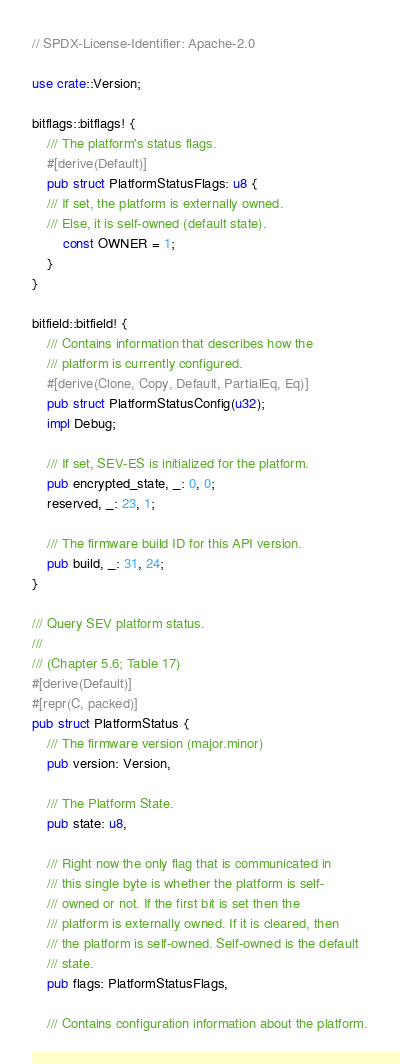<code> <loc_0><loc_0><loc_500><loc_500><_Rust_>// SPDX-License-Identifier: Apache-2.0

use crate::Version;

bitflags::bitflags! {
    /// The platform's status flags.
    #[derive(Default)]
    pub struct PlatformStatusFlags: u8 {
    /// If set, the platform is externally owned.
    /// Else, it is self-owned (default state).
        const OWNER = 1;
    }
}

bitfield::bitfield! {
    /// Contains information that describes how the
    /// platform is currently configured.
    #[derive(Clone, Copy, Default, PartialEq, Eq)]
    pub struct PlatformStatusConfig(u32);
    impl Debug;

    /// If set, SEV-ES is initialized for the platform.
    pub encrypted_state, _: 0, 0;
    reserved, _: 23, 1;

    /// The firmware build ID for this API version.
    pub build, _: 31, 24;
}

/// Query SEV platform status.
///
/// (Chapter 5.6; Table 17)
#[derive(Default)]
#[repr(C, packed)]
pub struct PlatformStatus {
    /// The firmware version (major.minor)
    pub version: Version,

    /// The Platform State.
    pub state: u8,

    /// Right now the only flag that is communicated in
    /// this single byte is whether the platform is self-
    /// owned or not. If the first bit is set then the
    /// platform is externally owned. If it is cleared, then
    /// the platform is self-owned. Self-owned is the default
    /// state.
    pub flags: PlatformStatusFlags,

    /// Contains configuration information about the platform.</code> 